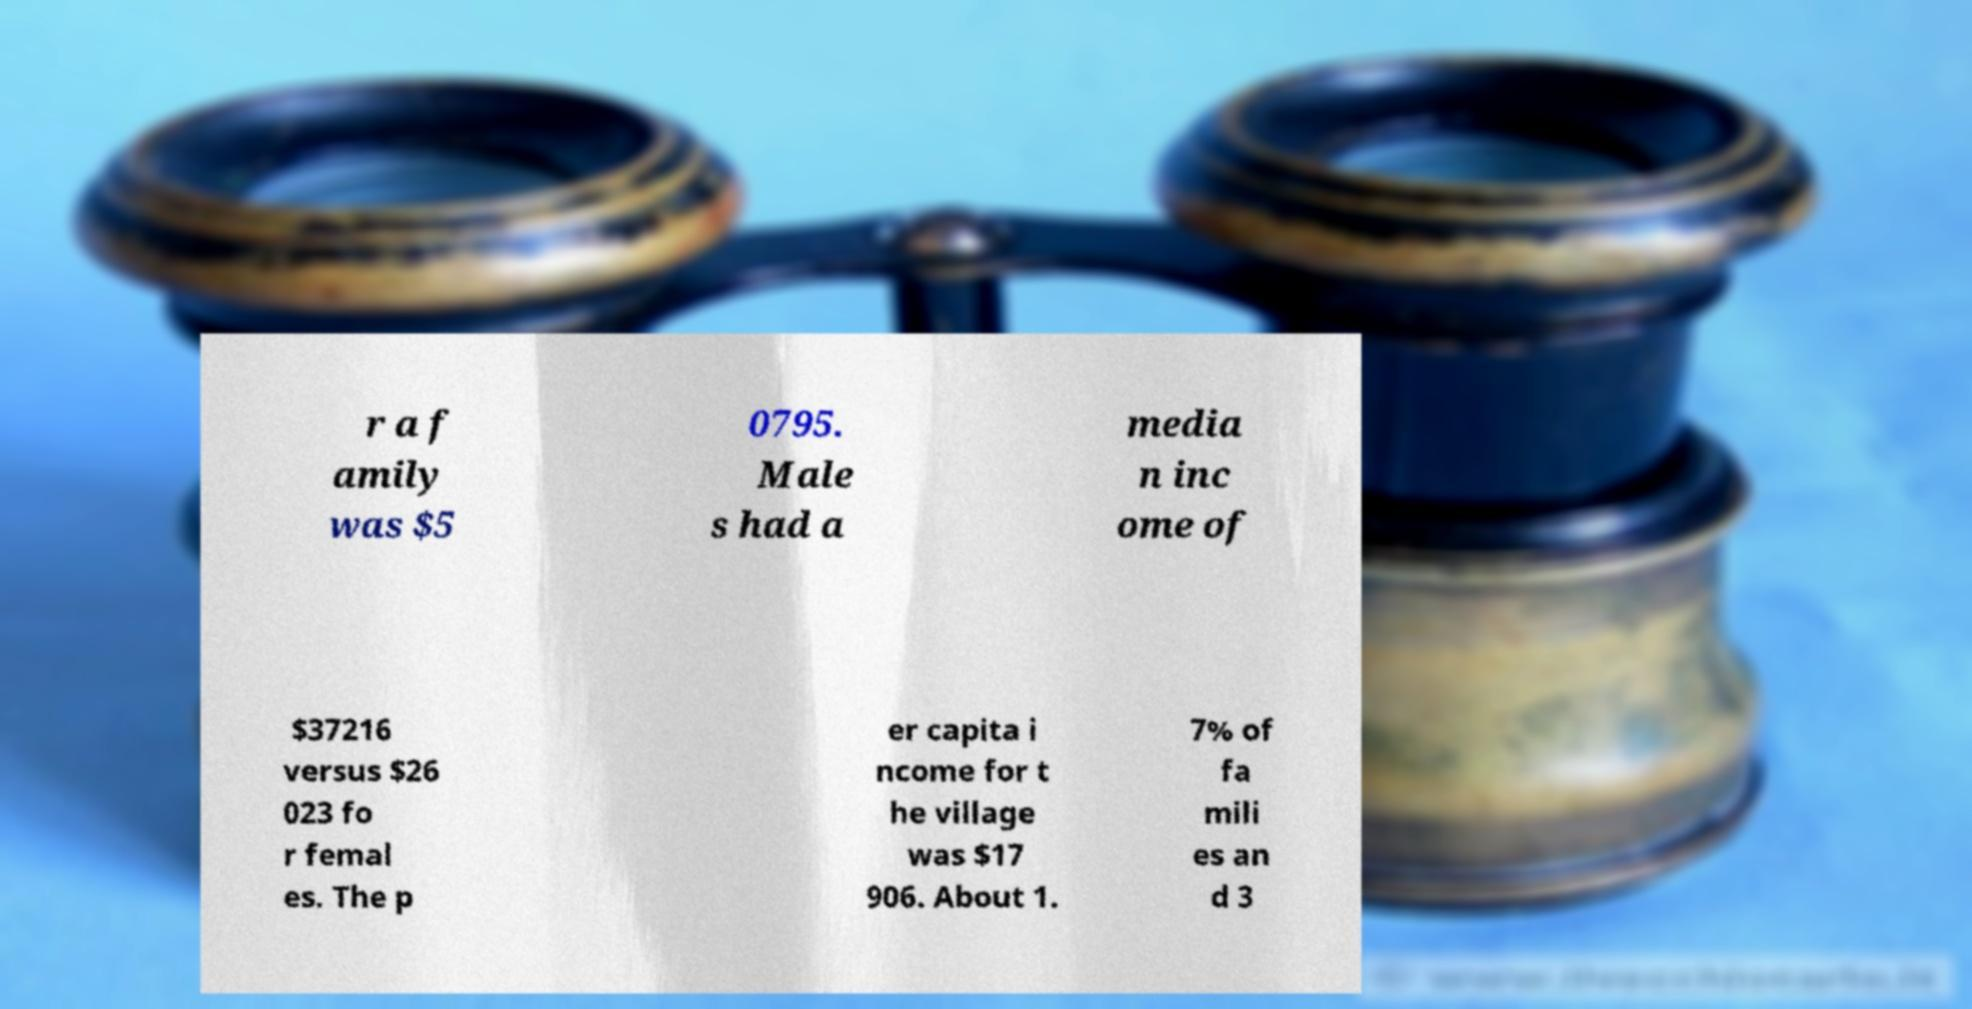What messages or text are displayed in this image? I need them in a readable, typed format. r a f amily was $5 0795. Male s had a media n inc ome of $37216 versus $26 023 fo r femal es. The p er capita i ncome for t he village was $17 906. About 1. 7% of fa mili es an d 3 